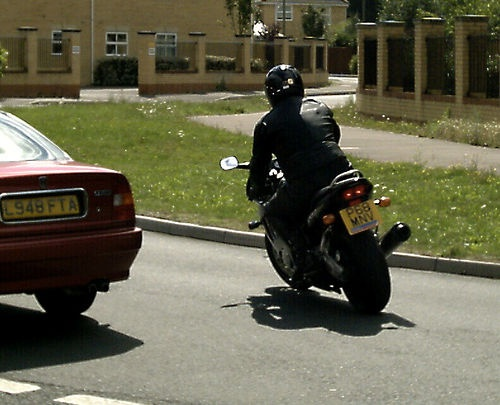Describe the objects in this image and their specific colors. I can see car in olive, black, white, and maroon tones, people in olive, black, gray, darkgray, and ivory tones, and motorcycle in olive, black, gray, and maroon tones in this image. 